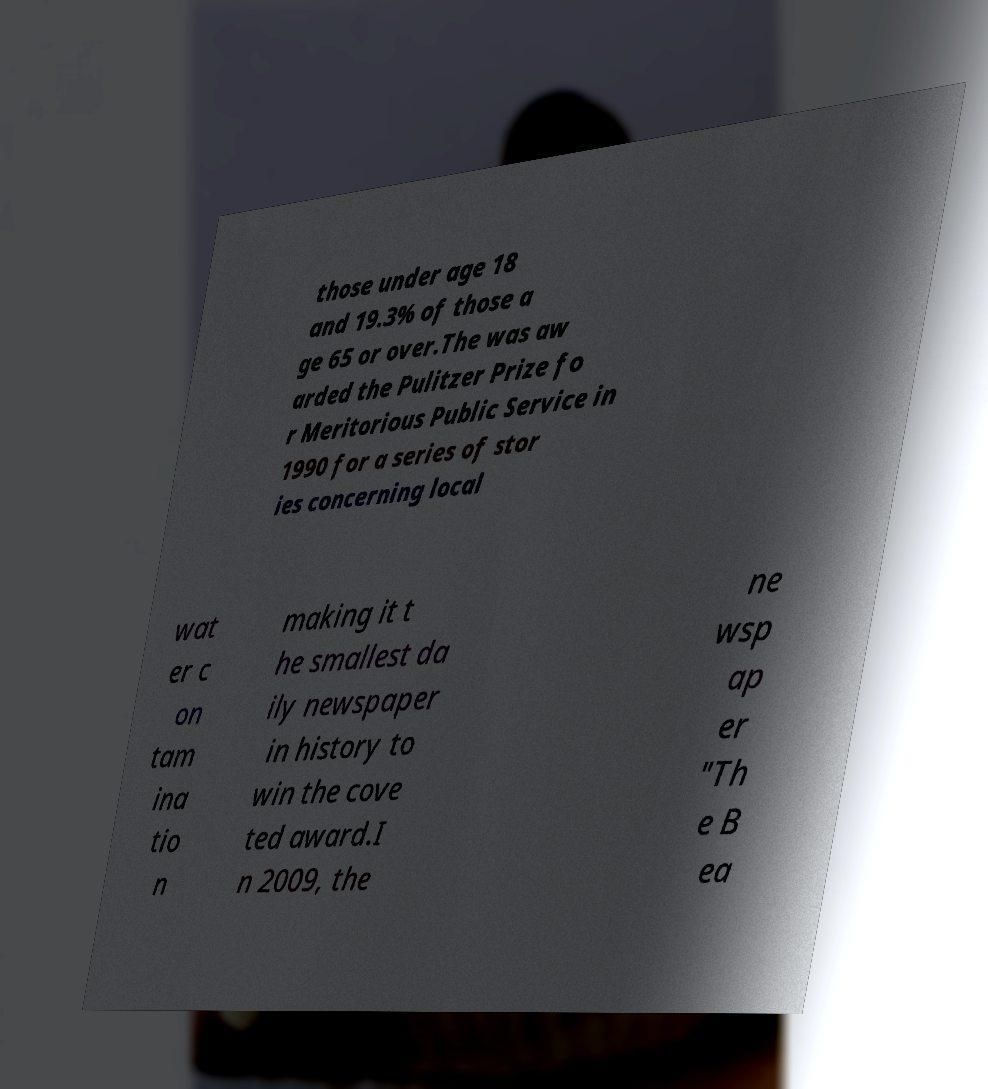Could you assist in decoding the text presented in this image and type it out clearly? those under age 18 and 19.3% of those a ge 65 or over.The was aw arded the Pulitzer Prize fo r Meritorious Public Service in 1990 for a series of stor ies concerning local wat er c on tam ina tio n making it t he smallest da ily newspaper in history to win the cove ted award.I n 2009, the ne wsp ap er "Th e B ea 